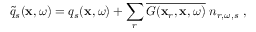<formula> <loc_0><loc_0><loc_500><loc_500>\widetilde { q } _ { s } ( x , \omega ) = q _ { s } ( x , \omega ) + \sum _ { r } \overline { { G ( x _ { r } , x , \omega ) } } \, n _ { r , \omega , s } \, ,</formula> 